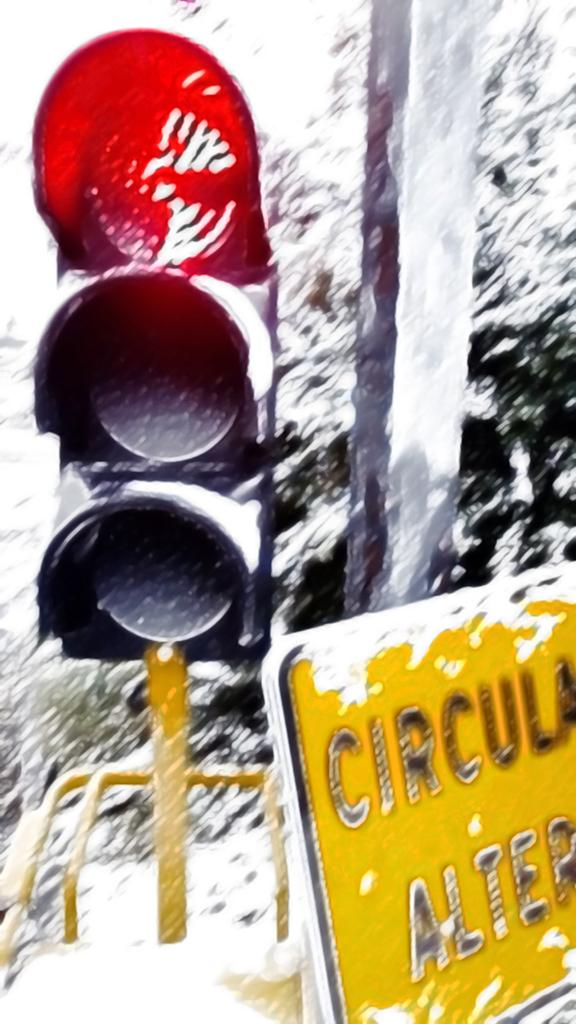<image>
Relay a brief, clear account of the picture shown. A red traffic light next to a sign that alerts drivers to a circular element in the road. 